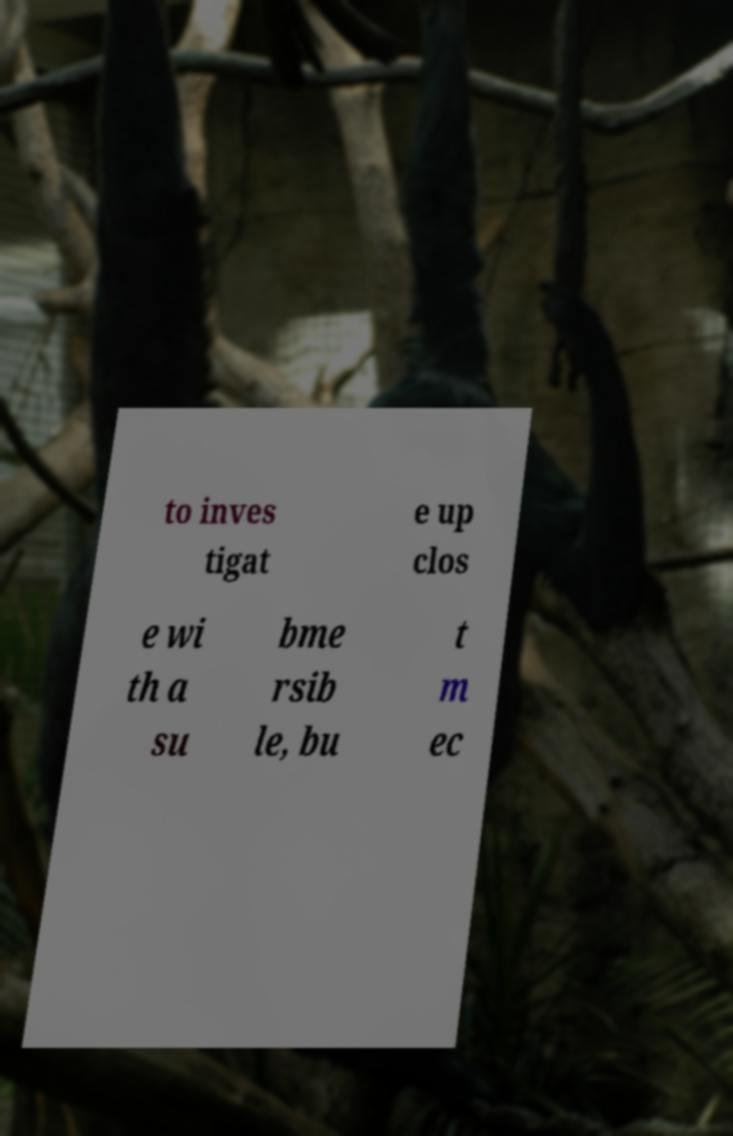I need the written content from this picture converted into text. Can you do that? to inves tigat e up clos e wi th a su bme rsib le, bu t m ec 